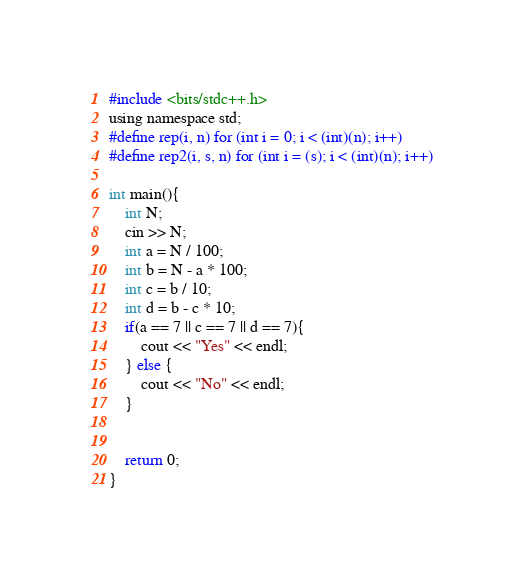<code> <loc_0><loc_0><loc_500><loc_500><_C_>#include <bits/stdc++.h>
using namespace std;
#define rep(i, n) for (int i = 0; i < (int)(n); i++)
#define rep2(i, s, n) for (int i = (s); i < (int)(n); i++)

int main(){
    int N;
    cin >> N;
    int a = N / 100;
    int b = N - a * 100;
    int c = b / 10;
    int d = b - c * 10;
    if(a == 7 || c == 7 || d == 7){
        cout << "Yes" << endl;
    } else {
        cout << "No" << endl;
    }


    return 0;
}
</code> 